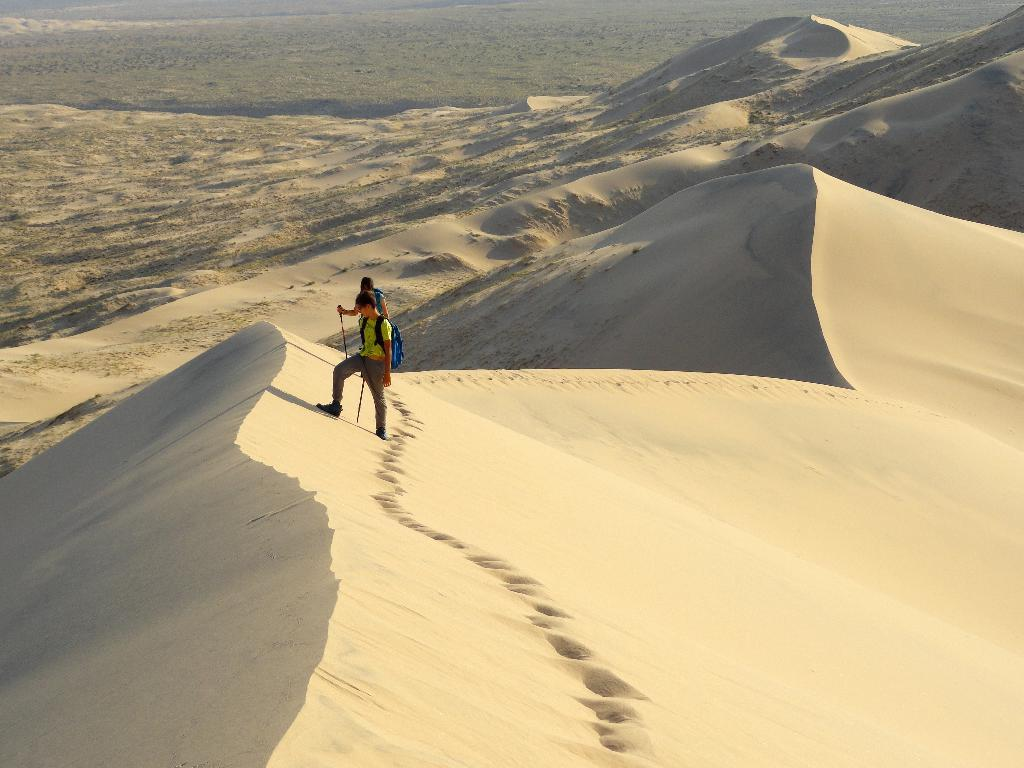How many people are present in the image? There are two people in the image. What are the two people doing in the image? The two people are climbing sand mountains. What type of thread is being used by the people to climb the sand mountains? There is no thread visible in the image, and the people are not using any thread to climb the sand mountains. 